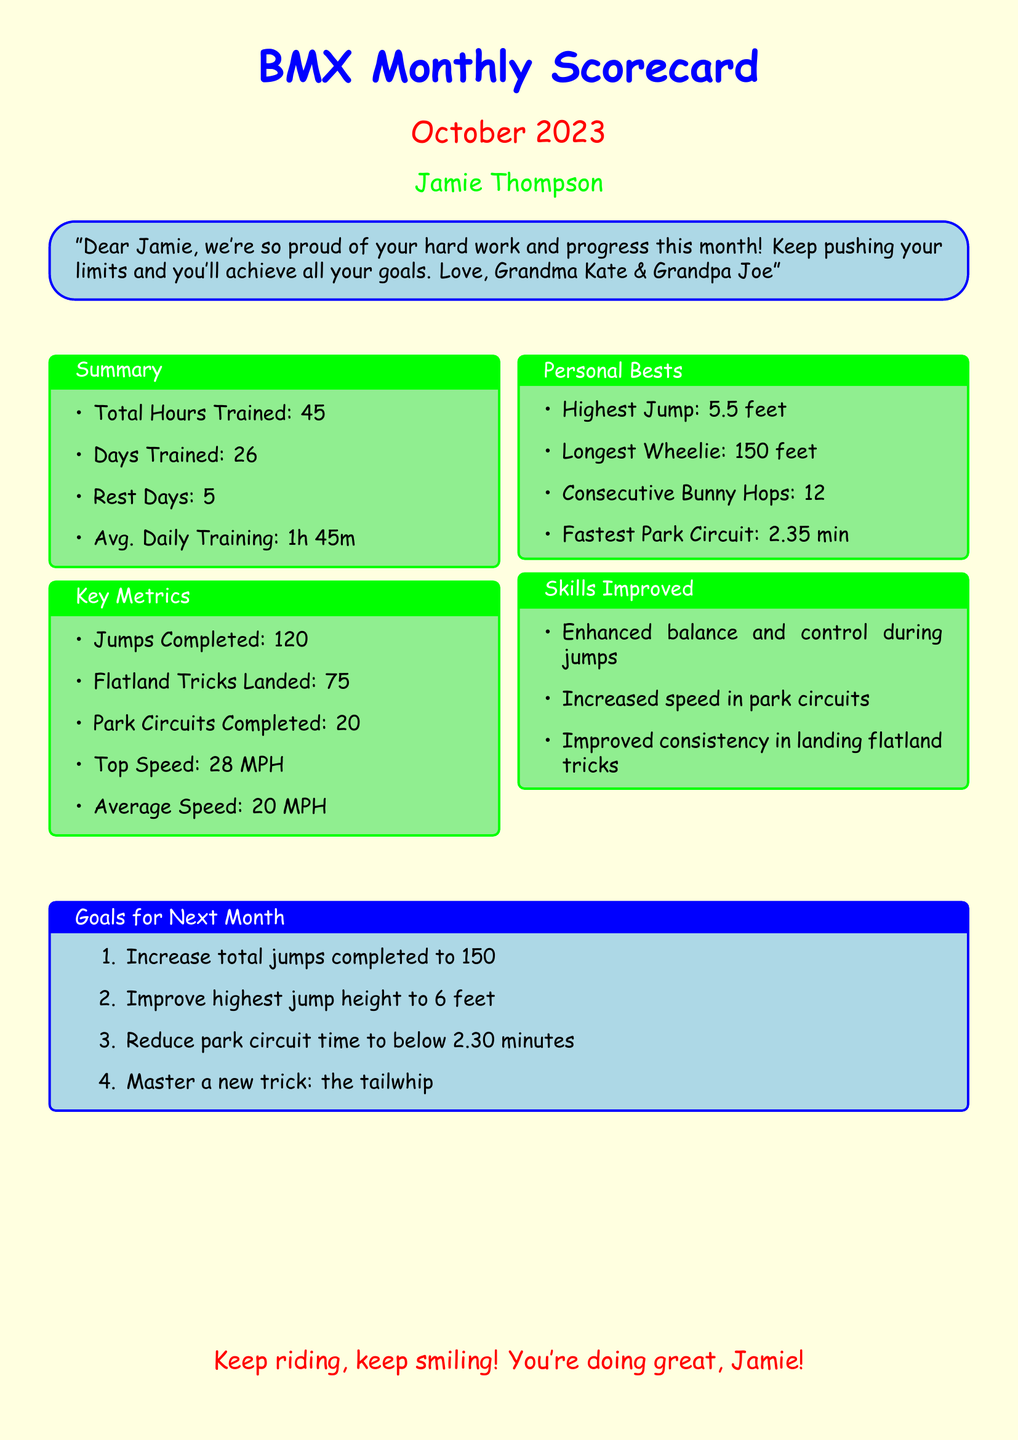What is the total hours trained? The total hours trained is specified in the Summary section of the document.
Answer: 45 How many days did Jamie train? The number of days Jamie trained is also mentioned in the Summary section.
Answer: 26 What is the top speed achieved? The top speed is a part of the Key Metrics section in the document.
Answer: 28 MPH What was the longest wheelie? The longest wheelie is recorded in the Personal Bests section.
Answer: 150 feet What is one of Jamie's goals for next month? Goals for next month are listed in the Goals for Next Month section, with specific objectives.
Answer: Increase total jumps completed to 150 How many flatland tricks did Jamie land? The number of flatland tricks landed is mentioned in the Key Metrics section.
Answer: 75 What skill improved regarding jumps? Improved skills are noted in the Skills Improved section, specifically mentioning jumps.
Answer: Enhanced balance and control during jumps What was Jamie's fastest park circuit time? The fastest park circuit time is provided in the Personal Bests section.
Answer: 2.35 min 